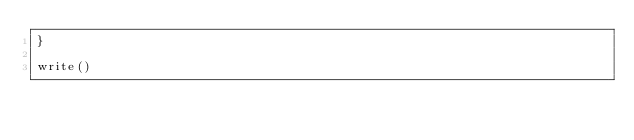<code> <loc_0><loc_0><loc_500><loc_500><_JavaScript_>}

write()
</code> 